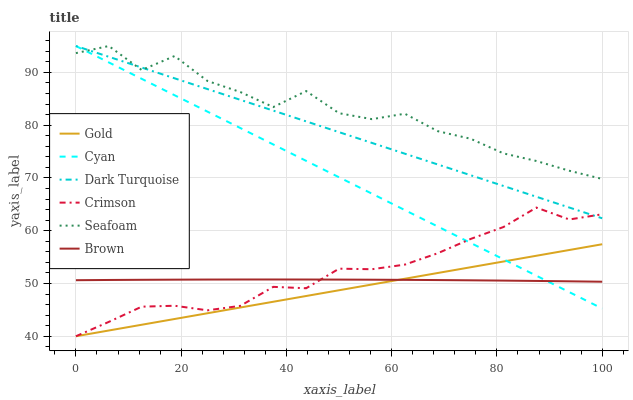Does Gold have the minimum area under the curve?
Answer yes or no. Yes. Does Seafoam have the maximum area under the curve?
Answer yes or no. Yes. Does Dark Turquoise have the minimum area under the curve?
Answer yes or no. No. Does Dark Turquoise have the maximum area under the curve?
Answer yes or no. No. Is Gold the smoothest?
Answer yes or no. Yes. Is Seafoam the roughest?
Answer yes or no. Yes. Is Dark Turquoise the smoothest?
Answer yes or no. No. Is Dark Turquoise the roughest?
Answer yes or no. No. Does Gold have the lowest value?
Answer yes or no. Yes. Does Dark Turquoise have the lowest value?
Answer yes or no. No. Does Cyan have the highest value?
Answer yes or no. Yes. Does Gold have the highest value?
Answer yes or no. No. Is Brown less than Dark Turquoise?
Answer yes or no. Yes. Is Dark Turquoise greater than Brown?
Answer yes or no. Yes. Does Brown intersect Crimson?
Answer yes or no. Yes. Is Brown less than Crimson?
Answer yes or no. No. Is Brown greater than Crimson?
Answer yes or no. No. Does Brown intersect Dark Turquoise?
Answer yes or no. No. 